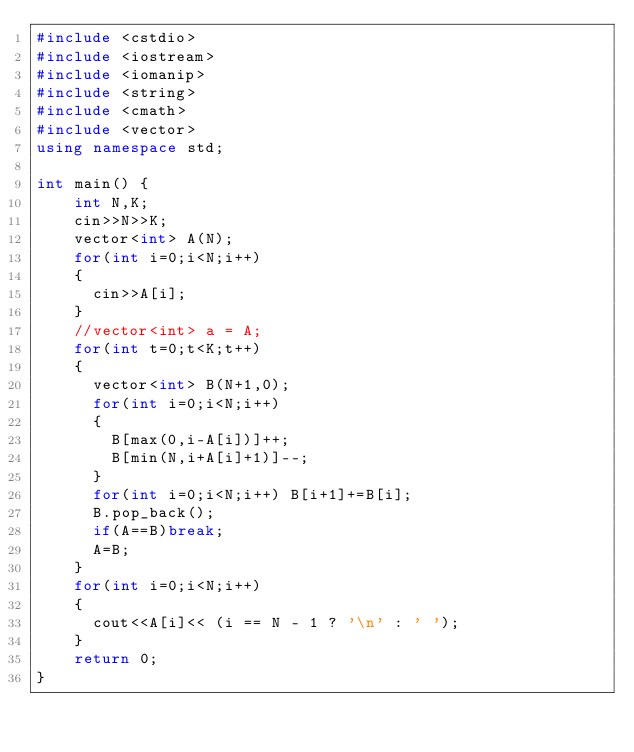Convert code to text. <code><loc_0><loc_0><loc_500><loc_500><_C++_>#include <cstdio>
#include <iostream>
#include <iomanip>
#include <string>
#include <cmath>
#include <vector>
using namespace std;
 
int main() {
    int N,K;
    cin>>N>>K;
    vector<int> A(N);
    for(int i=0;i<N;i++)
    {
      cin>>A[i];
    }
    //vector<int> a = A;
    for(int t=0;t<K;t++)
    {
      vector<int> B(N+1,0);
      for(int i=0;i<N;i++)
      {
        B[max(0,i-A[i])]++;
        B[min(N,i+A[i]+1)]--;
      }
      for(int i=0;i<N;i++) B[i+1]+=B[i];
      B.pop_back();
      if(A==B)break;
      A=B;
    }
    for(int i=0;i<N;i++)
    {
      cout<<A[i]<< (i == N - 1 ? '\n' : ' ');
    }
    return 0;
}</code> 